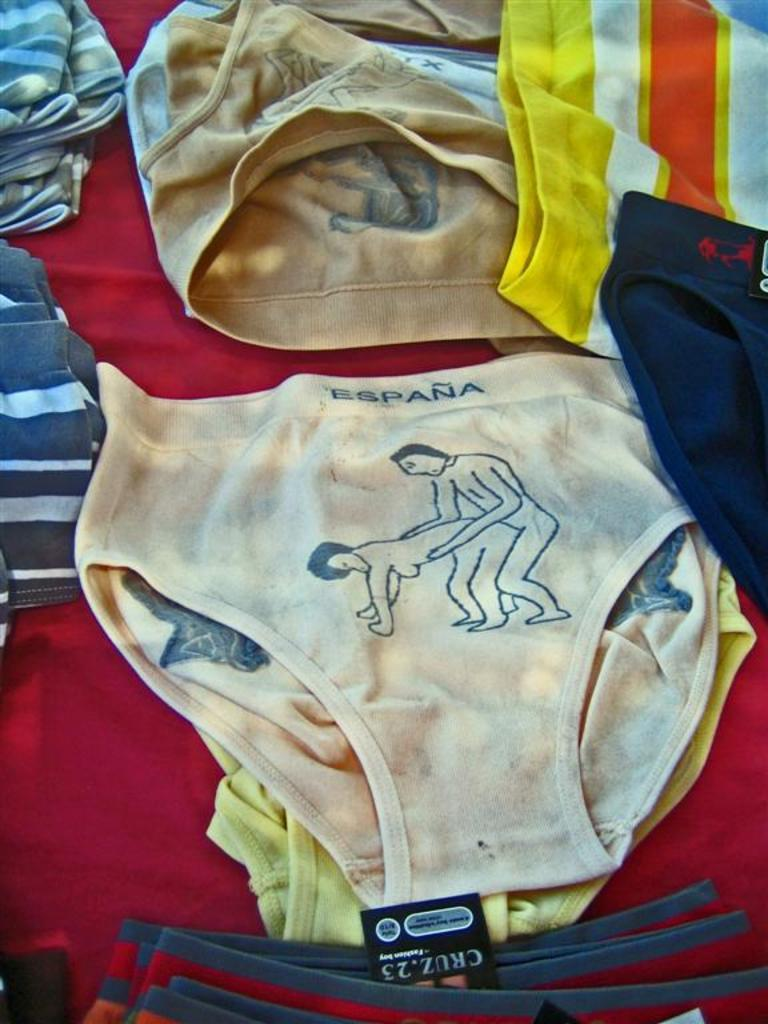What type of clothing is visible in the image? There are underwears in the image. Where are the underwears placed in the image? The underwears are on an object. What type of cabbage is growing on the tree in the image? There is no cabbage or tree present in the image; it only features underwears on an object. 